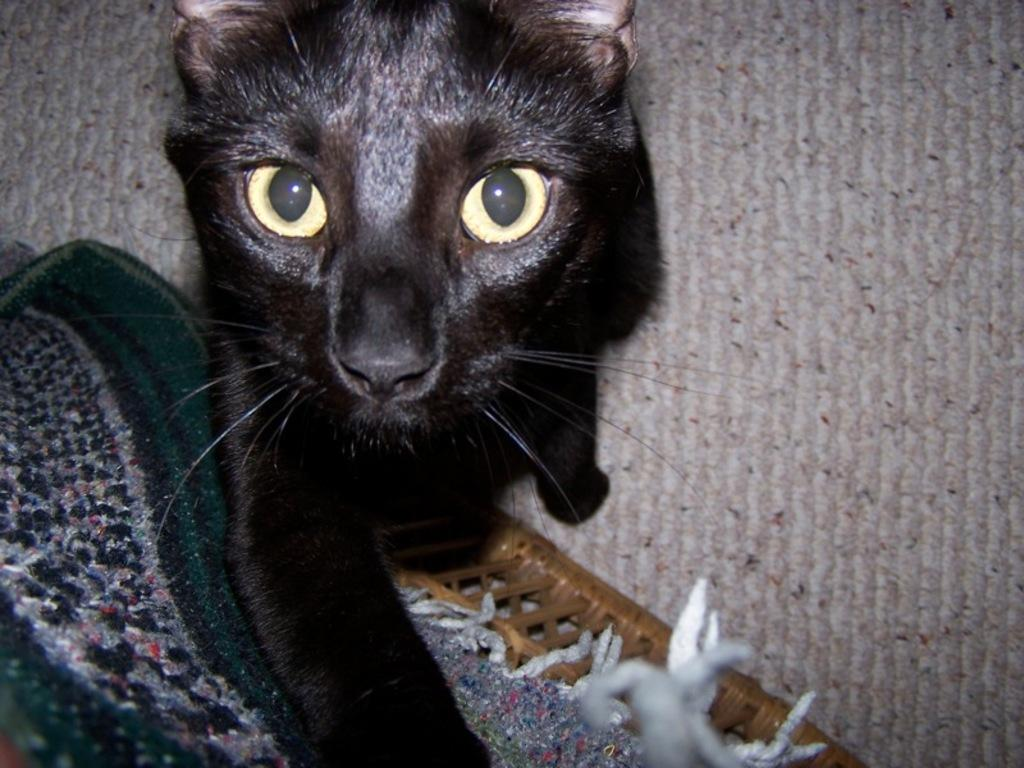What type of animal is in the image? There is a cat in the image. Where is the cat located? The cat is on a surface in the image. What other object can be seen in the image? There is a cloth in the image. How is the cloth positioned? The cloth is placed on a stool in the image. What type of advertisement is displayed on the cat's collar in the image? There is no advertisement or collar present on the cat in the image. 